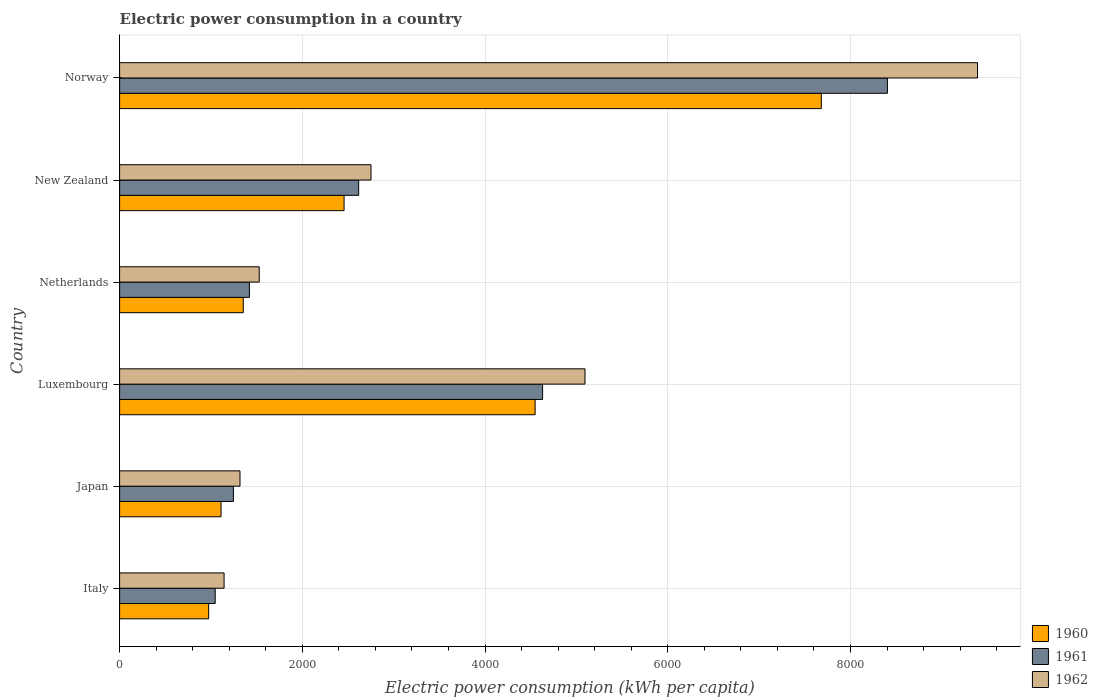How many different coloured bars are there?
Provide a short and direct response. 3. Are the number of bars per tick equal to the number of legend labels?
Your answer should be very brief. Yes. How many bars are there on the 6th tick from the top?
Make the answer very short. 3. How many bars are there on the 3rd tick from the bottom?
Provide a short and direct response. 3. What is the label of the 6th group of bars from the top?
Ensure brevity in your answer.  Italy. In how many cases, is the number of bars for a given country not equal to the number of legend labels?
Provide a short and direct response. 0. What is the electric power consumption in in 1960 in Luxembourg?
Make the answer very short. 4548.21. Across all countries, what is the maximum electric power consumption in in 1962?
Provide a succinct answer. 9390.98. Across all countries, what is the minimum electric power consumption in in 1960?
Your response must be concise. 975.03. In which country was the electric power consumption in in 1960 maximum?
Give a very brief answer. Norway. In which country was the electric power consumption in in 1962 minimum?
Offer a terse response. Italy. What is the total electric power consumption in in 1960 in the graph?
Your response must be concise. 1.81e+04. What is the difference between the electric power consumption in in 1960 in Luxembourg and that in Norway?
Ensure brevity in your answer.  -3132.94. What is the difference between the electric power consumption in in 1961 in New Zealand and the electric power consumption in in 1960 in Japan?
Your answer should be compact. 1506.59. What is the average electric power consumption in in 1962 per country?
Ensure brevity in your answer.  3537.86. What is the difference between the electric power consumption in in 1960 and electric power consumption in in 1961 in Italy?
Offer a terse response. -71.39. In how many countries, is the electric power consumption in in 1961 greater than 2000 kWh per capita?
Provide a succinct answer. 3. What is the ratio of the electric power consumption in in 1960 in New Zealand to that in Norway?
Your answer should be very brief. 0.32. Is the electric power consumption in in 1960 in Italy less than that in Netherlands?
Keep it short and to the point. Yes. Is the difference between the electric power consumption in in 1960 in Italy and Netherlands greater than the difference between the electric power consumption in in 1961 in Italy and Netherlands?
Make the answer very short. No. What is the difference between the highest and the second highest electric power consumption in in 1962?
Keep it short and to the point. 4296.67. What is the difference between the highest and the lowest electric power consumption in in 1960?
Keep it short and to the point. 6706.11. In how many countries, is the electric power consumption in in 1962 greater than the average electric power consumption in in 1962 taken over all countries?
Ensure brevity in your answer.  2. Is the sum of the electric power consumption in in 1960 in Japan and Norway greater than the maximum electric power consumption in in 1961 across all countries?
Offer a terse response. Yes. What does the 1st bar from the top in New Zealand represents?
Your answer should be compact. 1962. What does the 1st bar from the bottom in Luxembourg represents?
Ensure brevity in your answer.  1960. Is it the case that in every country, the sum of the electric power consumption in in 1960 and electric power consumption in in 1961 is greater than the electric power consumption in in 1962?
Your answer should be very brief. Yes. How many bars are there?
Provide a short and direct response. 18. How many countries are there in the graph?
Ensure brevity in your answer.  6. Does the graph contain grids?
Make the answer very short. Yes. Where does the legend appear in the graph?
Offer a terse response. Bottom right. How many legend labels are there?
Your answer should be compact. 3. How are the legend labels stacked?
Give a very brief answer. Vertical. What is the title of the graph?
Keep it short and to the point. Electric power consumption in a country. What is the label or title of the X-axis?
Your response must be concise. Electric power consumption (kWh per capita). What is the label or title of the Y-axis?
Offer a very short reply. Country. What is the Electric power consumption (kWh per capita) in 1960 in Italy?
Offer a very short reply. 975.03. What is the Electric power consumption (kWh per capita) in 1961 in Italy?
Offer a very short reply. 1046.42. What is the Electric power consumption (kWh per capita) in 1962 in Italy?
Your answer should be very brief. 1143.61. What is the Electric power consumption (kWh per capita) of 1960 in Japan?
Offer a very short reply. 1110.26. What is the Electric power consumption (kWh per capita) in 1961 in Japan?
Offer a very short reply. 1246.01. What is the Electric power consumption (kWh per capita) of 1962 in Japan?
Give a very brief answer. 1317.93. What is the Electric power consumption (kWh per capita) of 1960 in Luxembourg?
Give a very brief answer. 4548.21. What is the Electric power consumption (kWh per capita) of 1961 in Luxembourg?
Give a very brief answer. 4630.02. What is the Electric power consumption (kWh per capita) of 1962 in Luxembourg?
Provide a succinct answer. 5094.31. What is the Electric power consumption (kWh per capita) in 1960 in Netherlands?
Keep it short and to the point. 1353.4. What is the Electric power consumption (kWh per capita) of 1961 in Netherlands?
Provide a short and direct response. 1421.03. What is the Electric power consumption (kWh per capita) in 1962 in Netherlands?
Give a very brief answer. 1528.5. What is the Electric power consumption (kWh per capita) of 1960 in New Zealand?
Offer a very short reply. 2457.21. What is the Electric power consumption (kWh per capita) in 1961 in New Zealand?
Your answer should be very brief. 2616.85. What is the Electric power consumption (kWh per capita) of 1962 in New Zealand?
Your answer should be compact. 2751.81. What is the Electric power consumption (kWh per capita) of 1960 in Norway?
Ensure brevity in your answer.  7681.14. What is the Electric power consumption (kWh per capita) of 1961 in Norway?
Your answer should be compact. 8404.62. What is the Electric power consumption (kWh per capita) in 1962 in Norway?
Offer a terse response. 9390.98. Across all countries, what is the maximum Electric power consumption (kWh per capita) in 1960?
Provide a short and direct response. 7681.14. Across all countries, what is the maximum Electric power consumption (kWh per capita) in 1961?
Your response must be concise. 8404.62. Across all countries, what is the maximum Electric power consumption (kWh per capita) in 1962?
Provide a succinct answer. 9390.98. Across all countries, what is the minimum Electric power consumption (kWh per capita) in 1960?
Give a very brief answer. 975.03. Across all countries, what is the minimum Electric power consumption (kWh per capita) of 1961?
Your answer should be very brief. 1046.42. Across all countries, what is the minimum Electric power consumption (kWh per capita) of 1962?
Your answer should be very brief. 1143.61. What is the total Electric power consumption (kWh per capita) in 1960 in the graph?
Your answer should be very brief. 1.81e+04. What is the total Electric power consumption (kWh per capita) in 1961 in the graph?
Your answer should be very brief. 1.94e+04. What is the total Electric power consumption (kWh per capita) in 1962 in the graph?
Ensure brevity in your answer.  2.12e+04. What is the difference between the Electric power consumption (kWh per capita) of 1960 in Italy and that in Japan?
Ensure brevity in your answer.  -135.24. What is the difference between the Electric power consumption (kWh per capita) of 1961 in Italy and that in Japan?
Make the answer very short. -199.6. What is the difference between the Electric power consumption (kWh per capita) in 1962 in Italy and that in Japan?
Your answer should be compact. -174.33. What is the difference between the Electric power consumption (kWh per capita) in 1960 in Italy and that in Luxembourg?
Your response must be concise. -3573.18. What is the difference between the Electric power consumption (kWh per capita) of 1961 in Italy and that in Luxembourg?
Ensure brevity in your answer.  -3583.61. What is the difference between the Electric power consumption (kWh per capita) of 1962 in Italy and that in Luxembourg?
Your response must be concise. -3950.71. What is the difference between the Electric power consumption (kWh per capita) in 1960 in Italy and that in Netherlands?
Give a very brief answer. -378.37. What is the difference between the Electric power consumption (kWh per capita) of 1961 in Italy and that in Netherlands?
Ensure brevity in your answer.  -374.62. What is the difference between the Electric power consumption (kWh per capita) in 1962 in Italy and that in Netherlands?
Give a very brief answer. -384.9. What is the difference between the Electric power consumption (kWh per capita) in 1960 in Italy and that in New Zealand?
Your answer should be compact. -1482.18. What is the difference between the Electric power consumption (kWh per capita) of 1961 in Italy and that in New Zealand?
Ensure brevity in your answer.  -1570.44. What is the difference between the Electric power consumption (kWh per capita) of 1962 in Italy and that in New Zealand?
Ensure brevity in your answer.  -1608.21. What is the difference between the Electric power consumption (kWh per capita) in 1960 in Italy and that in Norway?
Provide a succinct answer. -6706.11. What is the difference between the Electric power consumption (kWh per capita) in 1961 in Italy and that in Norway?
Your answer should be very brief. -7358.21. What is the difference between the Electric power consumption (kWh per capita) in 1962 in Italy and that in Norway?
Provide a short and direct response. -8247.37. What is the difference between the Electric power consumption (kWh per capita) in 1960 in Japan and that in Luxembourg?
Make the answer very short. -3437.94. What is the difference between the Electric power consumption (kWh per capita) in 1961 in Japan and that in Luxembourg?
Ensure brevity in your answer.  -3384.01. What is the difference between the Electric power consumption (kWh per capita) of 1962 in Japan and that in Luxembourg?
Your answer should be very brief. -3776.38. What is the difference between the Electric power consumption (kWh per capita) of 1960 in Japan and that in Netherlands?
Provide a succinct answer. -243.14. What is the difference between the Electric power consumption (kWh per capita) of 1961 in Japan and that in Netherlands?
Your answer should be compact. -175.02. What is the difference between the Electric power consumption (kWh per capita) in 1962 in Japan and that in Netherlands?
Make the answer very short. -210.57. What is the difference between the Electric power consumption (kWh per capita) of 1960 in Japan and that in New Zealand?
Your response must be concise. -1346.94. What is the difference between the Electric power consumption (kWh per capita) in 1961 in Japan and that in New Zealand?
Ensure brevity in your answer.  -1370.84. What is the difference between the Electric power consumption (kWh per capita) in 1962 in Japan and that in New Zealand?
Offer a terse response. -1433.88. What is the difference between the Electric power consumption (kWh per capita) of 1960 in Japan and that in Norway?
Offer a terse response. -6570.88. What is the difference between the Electric power consumption (kWh per capita) of 1961 in Japan and that in Norway?
Give a very brief answer. -7158.61. What is the difference between the Electric power consumption (kWh per capita) of 1962 in Japan and that in Norway?
Make the answer very short. -8073.05. What is the difference between the Electric power consumption (kWh per capita) of 1960 in Luxembourg and that in Netherlands?
Ensure brevity in your answer.  3194.81. What is the difference between the Electric power consumption (kWh per capita) of 1961 in Luxembourg and that in Netherlands?
Make the answer very short. 3208.99. What is the difference between the Electric power consumption (kWh per capita) of 1962 in Luxembourg and that in Netherlands?
Offer a terse response. 3565.81. What is the difference between the Electric power consumption (kWh per capita) in 1960 in Luxembourg and that in New Zealand?
Ensure brevity in your answer.  2091. What is the difference between the Electric power consumption (kWh per capita) in 1961 in Luxembourg and that in New Zealand?
Your answer should be very brief. 2013.17. What is the difference between the Electric power consumption (kWh per capita) of 1962 in Luxembourg and that in New Zealand?
Offer a terse response. 2342.5. What is the difference between the Electric power consumption (kWh per capita) in 1960 in Luxembourg and that in Norway?
Your response must be concise. -3132.94. What is the difference between the Electric power consumption (kWh per capita) of 1961 in Luxembourg and that in Norway?
Your response must be concise. -3774.6. What is the difference between the Electric power consumption (kWh per capita) in 1962 in Luxembourg and that in Norway?
Provide a short and direct response. -4296.67. What is the difference between the Electric power consumption (kWh per capita) of 1960 in Netherlands and that in New Zealand?
Offer a very short reply. -1103.81. What is the difference between the Electric power consumption (kWh per capita) of 1961 in Netherlands and that in New Zealand?
Keep it short and to the point. -1195.82. What is the difference between the Electric power consumption (kWh per capita) in 1962 in Netherlands and that in New Zealand?
Provide a short and direct response. -1223.31. What is the difference between the Electric power consumption (kWh per capita) in 1960 in Netherlands and that in Norway?
Provide a short and direct response. -6327.74. What is the difference between the Electric power consumption (kWh per capita) of 1961 in Netherlands and that in Norway?
Provide a succinct answer. -6983.59. What is the difference between the Electric power consumption (kWh per capita) of 1962 in Netherlands and that in Norway?
Offer a terse response. -7862.48. What is the difference between the Electric power consumption (kWh per capita) in 1960 in New Zealand and that in Norway?
Provide a short and direct response. -5223.94. What is the difference between the Electric power consumption (kWh per capita) in 1961 in New Zealand and that in Norway?
Your answer should be very brief. -5787.77. What is the difference between the Electric power consumption (kWh per capita) of 1962 in New Zealand and that in Norway?
Offer a very short reply. -6639.17. What is the difference between the Electric power consumption (kWh per capita) of 1960 in Italy and the Electric power consumption (kWh per capita) of 1961 in Japan?
Your answer should be compact. -270.99. What is the difference between the Electric power consumption (kWh per capita) in 1960 in Italy and the Electric power consumption (kWh per capita) in 1962 in Japan?
Offer a terse response. -342.91. What is the difference between the Electric power consumption (kWh per capita) of 1961 in Italy and the Electric power consumption (kWh per capita) of 1962 in Japan?
Provide a short and direct response. -271.52. What is the difference between the Electric power consumption (kWh per capita) in 1960 in Italy and the Electric power consumption (kWh per capita) in 1961 in Luxembourg?
Keep it short and to the point. -3655. What is the difference between the Electric power consumption (kWh per capita) in 1960 in Italy and the Electric power consumption (kWh per capita) in 1962 in Luxembourg?
Your answer should be compact. -4119.28. What is the difference between the Electric power consumption (kWh per capita) of 1961 in Italy and the Electric power consumption (kWh per capita) of 1962 in Luxembourg?
Keep it short and to the point. -4047.9. What is the difference between the Electric power consumption (kWh per capita) in 1960 in Italy and the Electric power consumption (kWh per capita) in 1961 in Netherlands?
Your response must be concise. -446.01. What is the difference between the Electric power consumption (kWh per capita) of 1960 in Italy and the Electric power consumption (kWh per capita) of 1962 in Netherlands?
Your answer should be compact. -553.47. What is the difference between the Electric power consumption (kWh per capita) of 1961 in Italy and the Electric power consumption (kWh per capita) of 1962 in Netherlands?
Your answer should be compact. -482.09. What is the difference between the Electric power consumption (kWh per capita) of 1960 in Italy and the Electric power consumption (kWh per capita) of 1961 in New Zealand?
Give a very brief answer. -1641.83. What is the difference between the Electric power consumption (kWh per capita) of 1960 in Italy and the Electric power consumption (kWh per capita) of 1962 in New Zealand?
Ensure brevity in your answer.  -1776.79. What is the difference between the Electric power consumption (kWh per capita) of 1961 in Italy and the Electric power consumption (kWh per capita) of 1962 in New Zealand?
Provide a short and direct response. -1705.4. What is the difference between the Electric power consumption (kWh per capita) of 1960 in Italy and the Electric power consumption (kWh per capita) of 1961 in Norway?
Your response must be concise. -7429.6. What is the difference between the Electric power consumption (kWh per capita) in 1960 in Italy and the Electric power consumption (kWh per capita) in 1962 in Norway?
Offer a very short reply. -8415.95. What is the difference between the Electric power consumption (kWh per capita) of 1961 in Italy and the Electric power consumption (kWh per capita) of 1962 in Norway?
Ensure brevity in your answer.  -8344.56. What is the difference between the Electric power consumption (kWh per capita) of 1960 in Japan and the Electric power consumption (kWh per capita) of 1961 in Luxembourg?
Give a very brief answer. -3519.76. What is the difference between the Electric power consumption (kWh per capita) in 1960 in Japan and the Electric power consumption (kWh per capita) in 1962 in Luxembourg?
Your answer should be very brief. -3984.05. What is the difference between the Electric power consumption (kWh per capita) of 1961 in Japan and the Electric power consumption (kWh per capita) of 1962 in Luxembourg?
Provide a short and direct response. -3848.3. What is the difference between the Electric power consumption (kWh per capita) in 1960 in Japan and the Electric power consumption (kWh per capita) in 1961 in Netherlands?
Give a very brief answer. -310.77. What is the difference between the Electric power consumption (kWh per capita) of 1960 in Japan and the Electric power consumption (kWh per capita) of 1962 in Netherlands?
Keep it short and to the point. -418.24. What is the difference between the Electric power consumption (kWh per capita) of 1961 in Japan and the Electric power consumption (kWh per capita) of 1962 in Netherlands?
Give a very brief answer. -282.49. What is the difference between the Electric power consumption (kWh per capita) in 1960 in Japan and the Electric power consumption (kWh per capita) in 1961 in New Zealand?
Keep it short and to the point. -1506.59. What is the difference between the Electric power consumption (kWh per capita) of 1960 in Japan and the Electric power consumption (kWh per capita) of 1962 in New Zealand?
Provide a succinct answer. -1641.55. What is the difference between the Electric power consumption (kWh per capita) of 1961 in Japan and the Electric power consumption (kWh per capita) of 1962 in New Zealand?
Your answer should be compact. -1505.8. What is the difference between the Electric power consumption (kWh per capita) in 1960 in Japan and the Electric power consumption (kWh per capita) in 1961 in Norway?
Give a very brief answer. -7294.36. What is the difference between the Electric power consumption (kWh per capita) in 1960 in Japan and the Electric power consumption (kWh per capita) in 1962 in Norway?
Give a very brief answer. -8280.71. What is the difference between the Electric power consumption (kWh per capita) in 1961 in Japan and the Electric power consumption (kWh per capita) in 1962 in Norway?
Provide a succinct answer. -8144.97. What is the difference between the Electric power consumption (kWh per capita) in 1960 in Luxembourg and the Electric power consumption (kWh per capita) in 1961 in Netherlands?
Keep it short and to the point. 3127.17. What is the difference between the Electric power consumption (kWh per capita) of 1960 in Luxembourg and the Electric power consumption (kWh per capita) of 1962 in Netherlands?
Provide a short and direct response. 3019.7. What is the difference between the Electric power consumption (kWh per capita) in 1961 in Luxembourg and the Electric power consumption (kWh per capita) in 1962 in Netherlands?
Your answer should be compact. 3101.52. What is the difference between the Electric power consumption (kWh per capita) in 1960 in Luxembourg and the Electric power consumption (kWh per capita) in 1961 in New Zealand?
Give a very brief answer. 1931.35. What is the difference between the Electric power consumption (kWh per capita) of 1960 in Luxembourg and the Electric power consumption (kWh per capita) of 1962 in New Zealand?
Ensure brevity in your answer.  1796.39. What is the difference between the Electric power consumption (kWh per capita) in 1961 in Luxembourg and the Electric power consumption (kWh per capita) in 1962 in New Zealand?
Provide a succinct answer. 1878.21. What is the difference between the Electric power consumption (kWh per capita) in 1960 in Luxembourg and the Electric power consumption (kWh per capita) in 1961 in Norway?
Your answer should be compact. -3856.42. What is the difference between the Electric power consumption (kWh per capita) in 1960 in Luxembourg and the Electric power consumption (kWh per capita) in 1962 in Norway?
Ensure brevity in your answer.  -4842.77. What is the difference between the Electric power consumption (kWh per capita) in 1961 in Luxembourg and the Electric power consumption (kWh per capita) in 1962 in Norway?
Provide a short and direct response. -4760.95. What is the difference between the Electric power consumption (kWh per capita) in 1960 in Netherlands and the Electric power consumption (kWh per capita) in 1961 in New Zealand?
Your answer should be compact. -1263.45. What is the difference between the Electric power consumption (kWh per capita) of 1960 in Netherlands and the Electric power consumption (kWh per capita) of 1962 in New Zealand?
Keep it short and to the point. -1398.41. What is the difference between the Electric power consumption (kWh per capita) of 1961 in Netherlands and the Electric power consumption (kWh per capita) of 1962 in New Zealand?
Make the answer very short. -1330.78. What is the difference between the Electric power consumption (kWh per capita) in 1960 in Netherlands and the Electric power consumption (kWh per capita) in 1961 in Norway?
Ensure brevity in your answer.  -7051.22. What is the difference between the Electric power consumption (kWh per capita) of 1960 in Netherlands and the Electric power consumption (kWh per capita) of 1962 in Norway?
Provide a succinct answer. -8037.58. What is the difference between the Electric power consumption (kWh per capita) in 1961 in Netherlands and the Electric power consumption (kWh per capita) in 1962 in Norway?
Ensure brevity in your answer.  -7969.94. What is the difference between the Electric power consumption (kWh per capita) in 1960 in New Zealand and the Electric power consumption (kWh per capita) in 1961 in Norway?
Offer a terse response. -5947.42. What is the difference between the Electric power consumption (kWh per capita) of 1960 in New Zealand and the Electric power consumption (kWh per capita) of 1962 in Norway?
Your answer should be compact. -6933.77. What is the difference between the Electric power consumption (kWh per capita) of 1961 in New Zealand and the Electric power consumption (kWh per capita) of 1962 in Norway?
Make the answer very short. -6774.12. What is the average Electric power consumption (kWh per capita) of 1960 per country?
Offer a very short reply. 3020.87. What is the average Electric power consumption (kWh per capita) in 1961 per country?
Your answer should be very brief. 3227.49. What is the average Electric power consumption (kWh per capita) of 1962 per country?
Give a very brief answer. 3537.86. What is the difference between the Electric power consumption (kWh per capita) of 1960 and Electric power consumption (kWh per capita) of 1961 in Italy?
Offer a very short reply. -71.39. What is the difference between the Electric power consumption (kWh per capita) in 1960 and Electric power consumption (kWh per capita) in 1962 in Italy?
Ensure brevity in your answer.  -168.58. What is the difference between the Electric power consumption (kWh per capita) of 1961 and Electric power consumption (kWh per capita) of 1962 in Italy?
Your response must be concise. -97.19. What is the difference between the Electric power consumption (kWh per capita) of 1960 and Electric power consumption (kWh per capita) of 1961 in Japan?
Ensure brevity in your answer.  -135.75. What is the difference between the Electric power consumption (kWh per capita) in 1960 and Electric power consumption (kWh per capita) in 1962 in Japan?
Your answer should be very brief. -207.67. What is the difference between the Electric power consumption (kWh per capita) in 1961 and Electric power consumption (kWh per capita) in 1962 in Japan?
Ensure brevity in your answer.  -71.92. What is the difference between the Electric power consumption (kWh per capita) in 1960 and Electric power consumption (kWh per capita) in 1961 in Luxembourg?
Give a very brief answer. -81.82. What is the difference between the Electric power consumption (kWh per capita) of 1960 and Electric power consumption (kWh per capita) of 1962 in Luxembourg?
Your response must be concise. -546.11. What is the difference between the Electric power consumption (kWh per capita) in 1961 and Electric power consumption (kWh per capita) in 1962 in Luxembourg?
Your answer should be very brief. -464.29. What is the difference between the Electric power consumption (kWh per capita) in 1960 and Electric power consumption (kWh per capita) in 1961 in Netherlands?
Your answer should be compact. -67.63. What is the difference between the Electric power consumption (kWh per capita) of 1960 and Electric power consumption (kWh per capita) of 1962 in Netherlands?
Offer a very short reply. -175.1. What is the difference between the Electric power consumption (kWh per capita) in 1961 and Electric power consumption (kWh per capita) in 1962 in Netherlands?
Offer a terse response. -107.47. What is the difference between the Electric power consumption (kWh per capita) in 1960 and Electric power consumption (kWh per capita) in 1961 in New Zealand?
Offer a very short reply. -159.65. What is the difference between the Electric power consumption (kWh per capita) in 1960 and Electric power consumption (kWh per capita) in 1962 in New Zealand?
Your answer should be very brief. -294.61. What is the difference between the Electric power consumption (kWh per capita) in 1961 and Electric power consumption (kWh per capita) in 1962 in New Zealand?
Your answer should be compact. -134.96. What is the difference between the Electric power consumption (kWh per capita) of 1960 and Electric power consumption (kWh per capita) of 1961 in Norway?
Provide a short and direct response. -723.48. What is the difference between the Electric power consumption (kWh per capita) of 1960 and Electric power consumption (kWh per capita) of 1962 in Norway?
Provide a short and direct response. -1709.84. What is the difference between the Electric power consumption (kWh per capita) of 1961 and Electric power consumption (kWh per capita) of 1962 in Norway?
Keep it short and to the point. -986.36. What is the ratio of the Electric power consumption (kWh per capita) of 1960 in Italy to that in Japan?
Ensure brevity in your answer.  0.88. What is the ratio of the Electric power consumption (kWh per capita) of 1961 in Italy to that in Japan?
Make the answer very short. 0.84. What is the ratio of the Electric power consumption (kWh per capita) in 1962 in Italy to that in Japan?
Give a very brief answer. 0.87. What is the ratio of the Electric power consumption (kWh per capita) in 1960 in Italy to that in Luxembourg?
Your response must be concise. 0.21. What is the ratio of the Electric power consumption (kWh per capita) in 1961 in Italy to that in Luxembourg?
Provide a short and direct response. 0.23. What is the ratio of the Electric power consumption (kWh per capita) in 1962 in Italy to that in Luxembourg?
Your response must be concise. 0.22. What is the ratio of the Electric power consumption (kWh per capita) in 1960 in Italy to that in Netherlands?
Offer a terse response. 0.72. What is the ratio of the Electric power consumption (kWh per capita) of 1961 in Italy to that in Netherlands?
Give a very brief answer. 0.74. What is the ratio of the Electric power consumption (kWh per capita) in 1962 in Italy to that in Netherlands?
Keep it short and to the point. 0.75. What is the ratio of the Electric power consumption (kWh per capita) of 1960 in Italy to that in New Zealand?
Ensure brevity in your answer.  0.4. What is the ratio of the Electric power consumption (kWh per capita) of 1961 in Italy to that in New Zealand?
Offer a terse response. 0.4. What is the ratio of the Electric power consumption (kWh per capita) in 1962 in Italy to that in New Zealand?
Your answer should be compact. 0.42. What is the ratio of the Electric power consumption (kWh per capita) of 1960 in Italy to that in Norway?
Keep it short and to the point. 0.13. What is the ratio of the Electric power consumption (kWh per capita) of 1961 in Italy to that in Norway?
Your answer should be very brief. 0.12. What is the ratio of the Electric power consumption (kWh per capita) in 1962 in Italy to that in Norway?
Give a very brief answer. 0.12. What is the ratio of the Electric power consumption (kWh per capita) of 1960 in Japan to that in Luxembourg?
Provide a short and direct response. 0.24. What is the ratio of the Electric power consumption (kWh per capita) of 1961 in Japan to that in Luxembourg?
Provide a short and direct response. 0.27. What is the ratio of the Electric power consumption (kWh per capita) in 1962 in Japan to that in Luxembourg?
Give a very brief answer. 0.26. What is the ratio of the Electric power consumption (kWh per capita) of 1960 in Japan to that in Netherlands?
Your response must be concise. 0.82. What is the ratio of the Electric power consumption (kWh per capita) of 1961 in Japan to that in Netherlands?
Your response must be concise. 0.88. What is the ratio of the Electric power consumption (kWh per capita) in 1962 in Japan to that in Netherlands?
Offer a terse response. 0.86. What is the ratio of the Electric power consumption (kWh per capita) of 1960 in Japan to that in New Zealand?
Provide a short and direct response. 0.45. What is the ratio of the Electric power consumption (kWh per capita) of 1961 in Japan to that in New Zealand?
Ensure brevity in your answer.  0.48. What is the ratio of the Electric power consumption (kWh per capita) in 1962 in Japan to that in New Zealand?
Provide a succinct answer. 0.48. What is the ratio of the Electric power consumption (kWh per capita) of 1960 in Japan to that in Norway?
Your answer should be very brief. 0.14. What is the ratio of the Electric power consumption (kWh per capita) in 1961 in Japan to that in Norway?
Make the answer very short. 0.15. What is the ratio of the Electric power consumption (kWh per capita) of 1962 in Japan to that in Norway?
Provide a short and direct response. 0.14. What is the ratio of the Electric power consumption (kWh per capita) of 1960 in Luxembourg to that in Netherlands?
Give a very brief answer. 3.36. What is the ratio of the Electric power consumption (kWh per capita) of 1961 in Luxembourg to that in Netherlands?
Ensure brevity in your answer.  3.26. What is the ratio of the Electric power consumption (kWh per capita) of 1962 in Luxembourg to that in Netherlands?
Provide a short and direct response. 3.33. What is the ratio of the Electric power consumption (kWh per capita) of 1960 in Luxembourg to that in New Zealand?
Your answer should be compact. 1.85. What is the ratio of the Electric power consumption (kWh per capita) of 1961 in Luxembourg to that in New Zealand?
Your answer should be very brief. 1.77. What is the ratio of the Electric power consumption (kWh per capita) of 1962 in Luxembourg to that in New Zealand?
Make the answer very short. 1.85. What is the ratio of the Electric power consumption (kWh per capita) in 1960 in Luxembourg to that in Norway?
Your response must be concise. 0.59. What is the ratio of the Electric power consumption (kWh per capita) in 1961 in Luxembourg to that in Norway?
Ensure brevity in your answer.  0.55. What is the ratio of the Electric power consumption (kWh per capita) of 1962 in Luxembourg to that in Norway?
Your answer should be very brief. 0.54. What is the ratio of the Electric power consumption (kWh per capita) in 1960 in Netherlands to that in New Zealand?
Offer a terse response. 0.55. What is the ratio of the Electric power consumption (kWh per capita) of 1961 in Netherlands to that in New Zealand?
Offer a terse response. 0.54. What is the ratio of the Electric power consumption (kWh per capita) of 1962 in Netherlands to that in New Zealand?
Offer a very short reply. 0.56. What is the ratio of the Electric power consumption (kWh per capita) of 1960 in Netherlands to that in Norway?
Give a very brief answer. 0.18. What is the ratio of the Electric power consumption (kWh per capita) in 1961 in Netherlands to that in Norway?
Keep it short and to the point. 0.17. What is the ratio of the Electric power consumption (kWh per capita) in 1962 in Netherlands to that in Norway?
Offer a very short reply. 0.16. What is the ratio of the Electric power consumption (kWh per capita) of 1960 in New Zealand to that in Norway?
Offer a very short reply. 0.32. What is the ratio of the Electric power consumption (kWh per capita) in 1961 in New Zealand to that in Norway?
Make the answer very short. 0.31. What is the ratio of the Electric power consumption (kWh per capita) of 1962 in New Zealand to that in Norway?
Give a very brief answer. 0.29. What is the difference between the highest and the second highest Electric power consumption (kWh per capita) of 1960?
Ensure brevity in your answer.  3132.94. What is the difference between the highest and the second highest Electric power consumption (kWh per capita) of 1961?
Offer a terse response. 3774.6. What is the difference between the highest and the second highest Electric power consumption (kWh per capita) of 1962?
Ensure brevity in your answer.  4296.67. What is the difference between the highest and the lowest Electric power consumption (kWh per capita) in 1960?
Give a very brief answer. 6706.11. What is the difference between the highest and the lowest Electric power consumption (kWh per capita) of 1961?
Offer a terse response. 7358.21. What is the difference between the highest and the lowest Electric power consumption (kWh per capita) in 1962?
Make the answer very short. 8247.37. 